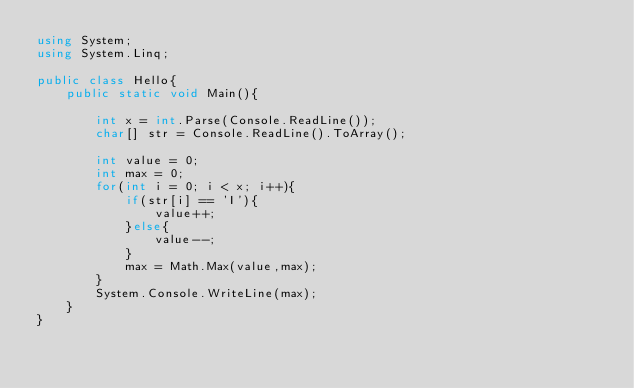Convert code to text. <code><loc_0><loc_0><loc_500><loc_500><_C#_>using System;
using System.Linq;

public class Hello{
    public static void Main(){

        int x = int.Parse(Console.ReadLine());
        char[] str = Console.ReadLine().ToArray();
        
        int value = 0;
        int max = 0;
        for(int i = 0; i < x; i++){
            if(str[i] == 'I'){
                value++;
            }else{
                value--;
            }
            max = Math.Max(value,max);
        }
        System.Console.WriteLine(max);
    }
}
</code> 